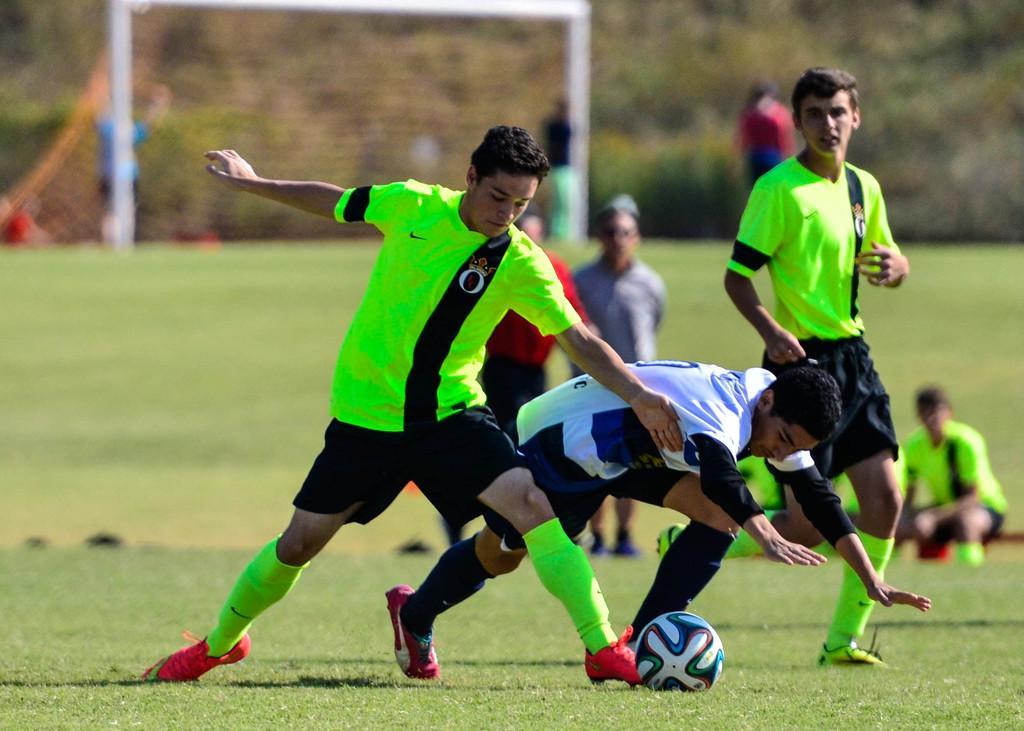Can you describe this image briefly? There are three people and we can see ball on the grass. Background it is blurry and we can see people. 